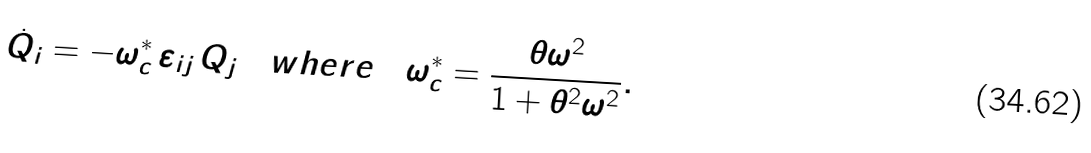<formula> <loc_0><loc_0><loc_500><loc_500>\dot { Q } _ { i } = - \omega _ { c } ^ { * } \, \varepsilon _ { i j } \, Q _ { j } \quad w h e r e \quad \omega _ { c } ^ { * } = \frac { \theta \omega ^ { 2 } } { 1 + \theta ^ { 2 } \omega ^ { 2 } } .</formula> 